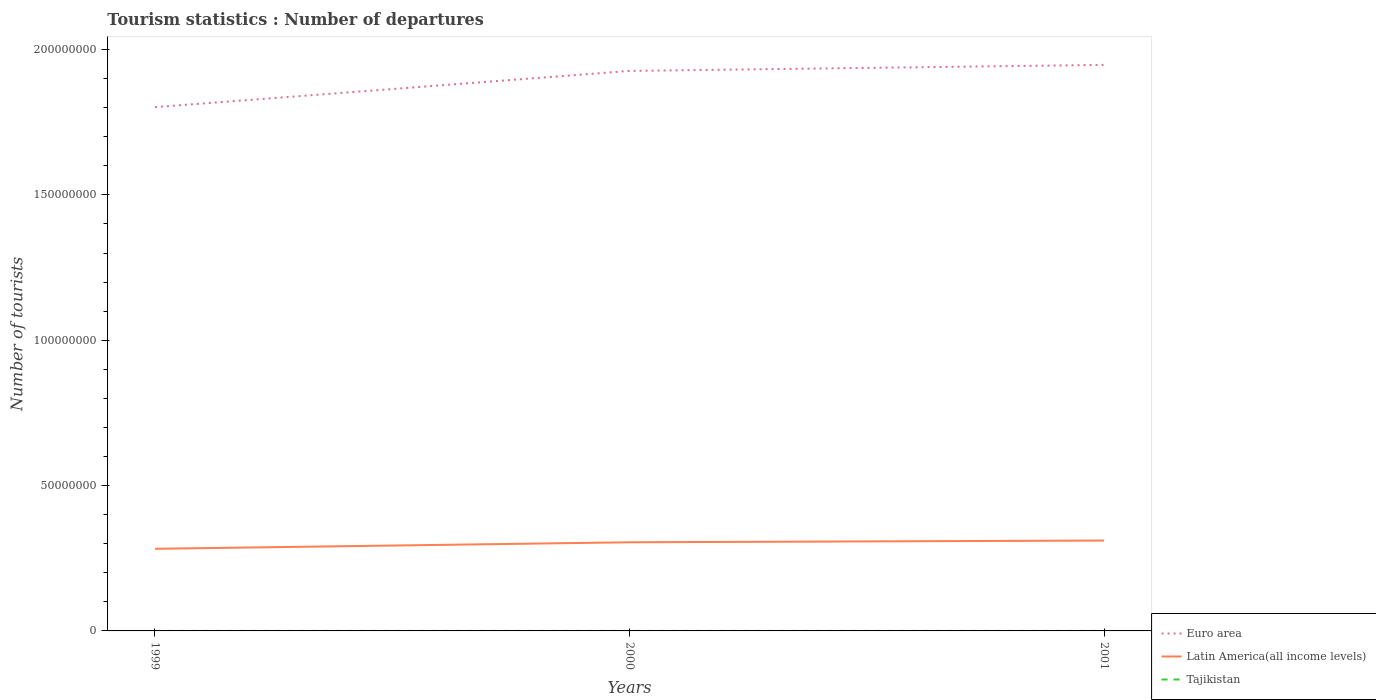Is the number of lines equal to the number of legend labels?
Your answer should be compact. Yes. Across all years, what is the maximum number of tourist departures in Latin America(all income levels)?
Ensure brevity in your answer.  2.83e+07. In which year was the number of tourist departures in Latin America(all income levels) maximum?
Ensure brevity in your answer.  1999. What is the total number of tourist departures in Euro area in the graph?
Offer a very short reply. -1.45e+07. What is the difference between the highest and the second highest number of tourist departures in Latin America(all income levels)?
Your answer should be compact. 2.84e+06. What is the difference between the highest and the lowest number of tourist departures in Euro area?
Offer a terse response. 2. Is the number of tourist departures in Euro area strictly greater than the number of tourist departures in Latin America(all income levels) over the years?
Make the answer very short. No. What is the difference between two consecutive major ticks on the Y-axis?
Provide a short and direct response. 5.00e+07. Does the graph contain any zero values?
Your response must be concise. No. How many legend labels are there?
Offer a very short reply. 3. What is the title of the graph?
Give a very brief answer. Tourism statistics : Number of departures. What is the label or title of the X-axis?
Keep it short and to the point. Years. What is the label or title of the Y-axis?
Your answer should be very brief. Number of tourists. What is the Number of tourists in Euro area in 1999?
Provide a short and direct response. 1.80e+08. What is the Number of tourists in Latin America(all income levels) in 1999?
Provide a short and direct response. 2.83e+07. What is the Number of tourists of Tajikistan in 1999?
Offer a very short reply. 4100. What is the Number of tourists of Euro area in 2000?
Provide a short and direct response. 1.93e+08. What is the Number of tourists of Latin America(all income levels) in 2000?
Provide a succinct answer. 3.05e+07. What is the Number of tourists of Tajikistan in 2000?
Offer a very short reply. 6400. What is the Number of tourists in Euro area in 2001?
Your answer should be compact. 1.95e+08. What is the Number of tourists of Latin America(all income levels) in 2001?
Give a very brief answer. 3.11e+07. What is the Number of tourists of Tajikistan in 2001?
Make the answer very short. 2700. Across all years, what is the maximum Number of tourists in Euro area?
Offer a very short reply. 1.95e+08. Across all years, what is the maximum Number of tourists in Latin America(all income levels)?
Your answer should be compact. 3.11e+07. Across all years, what is the maximum Number of tourists in Tajikistan?
Offer a terse response. 6400. Across all years, what is the minimum Number of tourists of Euro area?
Your answer should be very brief. 1.80e+08. Across all years, what is the minimum Number of tourists of Latin America(all income levels)?
Give a very brief answer. 2.83e+07. Across all years, what is the minimum Number of tourists in Tajikistan?
Ensure brevity in your answer.  2700. What is the total Number of tourists of Euro area in the graph?
Offer a very short reply. 5.68e+08. What is the total Number of tourists of Latin America(all income levels) in the graph?
Give a very brief answer. 8.98e+07. What is the total Number of tourists in Tajikistan in the graph?
Your response must be concise. 1.32e+04. What is the difference between the Number of tourists of Euro area in 1999 and that in 2000?
Your response must be concise. -1.25e+07. What is the difference between the Number of tourists of Latin America(all income levels) in 1999 and that in 2000?
Provide a succinct answer. -2.24e+06. What is the difference between the Number of tourists of Tajikistan in 1999 and that in 2000?
Offer a terse response. -2300. What is the difference between the Number of tourists in Euro area in 1999 and that in 2001?
Your answer should be compact. -1.45e+07. What is the difference between the Number of tourists of Latin America(all income levels) in 1999 and that in 2001?
Ensure brevity in your answer.  -2.84e+06. What is the difference between the Number of tourists in Tajikistan in 1999 and that in 2001?
Provide a short and direct response. 1400. What is the difference between the Number of tourists in Euro area in 2000 and that in 2001?
Make the answer very short. -2.08e+06. What is the difference between the Number of tourists of Latin America(all income levels) in 2000 and that in 2001?
Give a very brief answer. -6.03e+05. What is the difference between the Number of tourists of Tajikistan in 2000 and that in 2001?
Keep it short and to the point. 3700. What is the difference between the Number of tourists in Euro area in 1999 and the Number of tourists in Latin America(all income levels) in 2000?
Make the answer very short. 1.50e+08. What is the difference between the Number of tourists of Euro area in 1999 and the Number of tourists of Tajikistan in 2000?
Offer a terse response. 1.80e+08. What is the difference between the Number of tourists in Latin America(all income levels) in 1999 and the Number of tourists in Tajikistan in 2000?
Offer a very short reply. 2.82e+07. What is the difference between the Number of tourists in Euro area in 1999 and the Number of tourists in Latin America(all income levels) in 2001?
Provide a succinct answer. 1.49e+08. What is the difference between the Number of tourists of Euro area in 1999 and the Number of tourists of Tajikistan in 2001?
Keep it short and to the point. 1.80e+08. What is the difference between the Number of tourists in Latin America(all income levels) in 1999 and the Number of tourists in Tajikistan in 2001?
Your response must be concise. 2.82e+07. What is the difference between the Number of tourists in Euro area in 2000 and the Number of tourists in Latin America(all income levels) in 2001?
Your answer should be very brief. 1.62e+08. What is the difference between the Number of tourists in Euro area in 2000 and the Number of tourists in Tajikistan in 2001?
Make the answer very short. 1.93e+08. What is the difference between the Number of tourists in Latin America(all income levels) in 2000 and the Number of tourists in Tajikistan in 2001?
Make the answer very short. 3.05e+07. What is the average Number of tourists in Euro area per year?
Give a very brief answer. 1.89e+08. What is the average Number of tourists of Latin America(all income levels) per year?
Keep it short and to the point. 2.99e+07. What is the average Number of tourists in Tajikistan per year?
Your answer should be compact. 4400. In the year 1999, what is the difference between the Number of tourists in Euro area and Number of tourists in Latin America(all income levels)?
Offer a terse response. 1.52e+08. In the year 1999, what is the difference between the Number of tourists in Euro area and Number of tourists in Tajikistan?
Offer a very short reply. 1.80e+08. In the year 1999, what is the difference between the Number of tourists in Latin America(all income levels) and Number of tourists in Tajikistan?
Make the answer very short. 2.82e+07. In the year 2000, what is the difference between the Number of tourists in Euro area and Number of tourists in Latin America(all income levels)?
Your response must be concise. 1.62e+08. In the year 2000, what is the difference between the Number of tourists in Euro area and Number of tourists in Tajikistan?
Provide a succinct answer. 1.93e+08. In the year 2000, what is the difference between the Number of tourists of Latin America(all income levels) and Number of tourists of Tajikistan?
Your answer should be compact. 3.05e+07. In the year 2001, what is the difference between the Number of tourists in Euro area and Number of tourists in Latin America(all income levels)?
Provide a short and direct response. 1.64e+08. In the year 2001, what is the difference between the Number of tourists in Euro area and Number of tourists in Tajikistan?
Provide a succinct answer. 1.95e+08. In the year 2001, what is the difference between the Number of tourists in Latin America(all income levels) and Number of tourists in Tajikistan?
Offer a terse response. 3.11e+07. What is the ratio of the Number of tourists in Euro area in 1999 to that in 2000?
Provide a short and direct response. 0.94. What is the ratio of the Number of tourists in Latin America(all income levels) in 1999 to that in 2000?
Provide a succinct answer. 0.93. What is the ratio of the Number of tourists in Tajikistan in 1999 to that in 2000?
Keep it short and to the point. 0.64. What is the ratio of the Number of tourists of Euro area in 1999 to that in 2001?
Give a very brief answer. 0.93. What is the ratio of the Number of tourists in Latin America(all income levels) in 1999 to that in 2001?
Offer a very short reply. 0.91. What is the ratio of the Number of tourists of Tajikistan in 1999 to that in 2001?
Provide a succinct answer. 1.52. What is the ratio of the Number of tourists in Euro area in 2000 to that in 2001?
Ensure brevity in your answer.  0.99. What is the ratio of the Number of tourists of Latin America(all income levels) in 2000 to that in 2001?
Offer a terse response. 0.98. What is the ratio of the Number of tourists in Tajikistan in 2000 to that in 2001?
Provide a succinct answer. 2.37. What is the difference between the highest and the second highest Number of tourists of Euro area?
Ensure brevity in your answer.  2.08e+06. What is the difference between the highest and the second highest Number of tourists in Latin America(all income levels)?
Give a very brief answer. 6.03e+05. What is the difference between the highest and the second highest Number of tourists in Tajikistan?
Provide a short and direct response. 2300. What is the difference between the highest and the lowest Number of tourists of Euro area?
Offer a terse response. 1.45e+07. What is the difference between the highest and the lowest Number of tourists in Latin America(all income levels)?
Your answer should be compact. 2.84e+06. What is the difference between the highest and the lowest Number of tourists in Tajikistan?
Your answer should be very brief. 3700. 